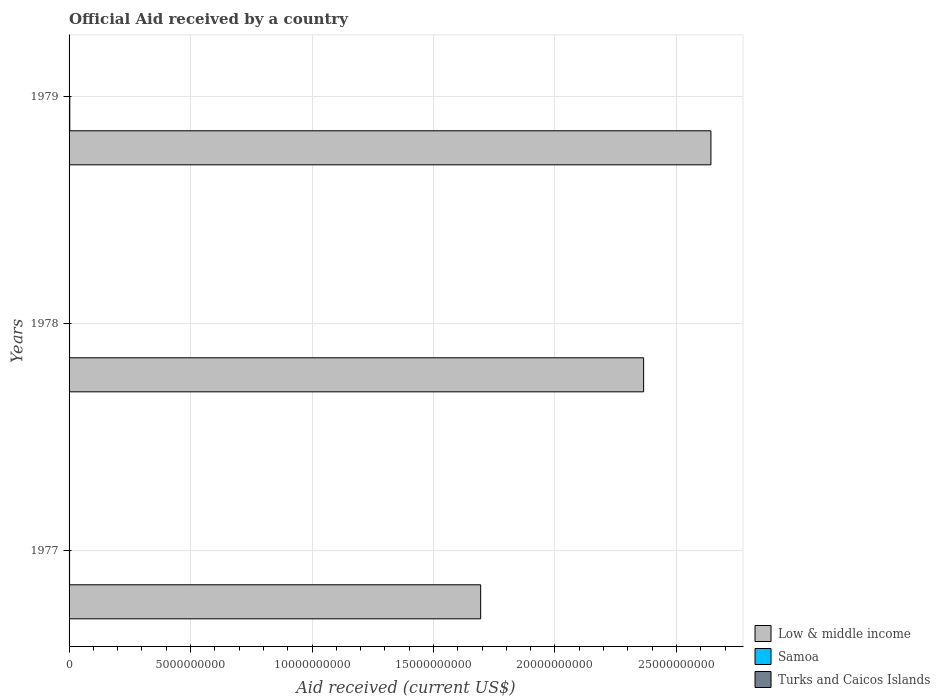How many bars are there on the 1st tick from the bottom?
Provide a short and direct response. 3. In how many cases, is the number of bars for a given year not equal to the number of legend labels?
Offer a very short reply. 0. What is the net official aid received in Samoa in 1977?
Your answer should be very brief. 2.00e+07. Across all years, what is the maximum net official aid received in Samoa?
Ensure brevity in your answer.  2.96e+07. Across all years, what is the minimum net official aid received in Low & middle income?
Keep it short and to the point. 1.69e+1. In which year was the net official aid received in Samoa minimum?
Keep it short and to the point. 1978. What is the total net official aid received in Samoa in the graph?
Your response must be concise. 6.96e+07. What is the difference between the net official aid received in Turks and Caicos Islands in 1978 and that in 1979?
Ensure brevity in your answer.  4.60e+05. What is the difference between the net official aid received in Low & middle income in 1979 and the net official aid received in Turks and Caicos Islands in 1978?
Your response must be concise. 2.64e+1. What is the average net official aid received in Turks and Caicos Islands per year?
Offer a terse response. 2.85e+06. In the year 1977, what is the difference between the net official aid received in Samoa and net official aid received in Low & middle income?
Provide a succinct answer. -1.69e+1. What is the ratio of the net official aid received in Turks and Caicos Islands in 1977 to that in 1979?
Make the answer very short. 1.49. Is the net official aid received in Low & middle income in 1977 less than that in 1978?
Your answer should be compact. Yes. What is the difference between the highest and the second highest net official aid received in Samoa?
Make the answer very short. 9.61e+06. What is the difference between the highest and the lowest net official aid received in Low & middle income?
Ensure brevity in your answer.  9.48e+09. Is the sum of the net official aid received in Turks and Caicos Islands in 1978 and 1979 greater than the maximum net official aid received in Low & middle income across all years?
Keep it short and to the point. No. What does the 2nd bar from the bottom in 1979 represents?
Offer a terse response. Samoa. How many bars are there?
Give a very brief answer. 9. Are all the bars in the graph horizontal?
Your answer should be very brief. Yes. Does the graph contain any zero values?
Offer a very short reply. No. Does the graph contain grids?
Ensure brevity in your answer.  Yes. How many legend labels are there?
Offer a terse response. 3. How are the legend labels stacked?
Offer a very short reply. Vertical. What is the title of the graph?
Offer a terse response. Official Aid received by a country. What is the label or title of the X-axis?
Give a very brief answer. Aid received (current US$). What is the label or title of the Y-axis?
Ensure brevity in your answer.  Years. What is the Aid received (current US$) in Low & middle income in 1977?
Your answer should be compact. 1.69e+1. What is the Aid received (current US$) in Samoa in 1977?
Provide a succinct answer. 2.00e+07. What is the Aid received (current US$) of Turks and Caicos Islands in 1977?
Offer a terse response. 3.45e+06. What is the Aid received (current US$) in Low & middle income in 1978?
Give a very brief answer. 2.37e+1. What is the Aid received (current US$) of Samoa in 1978?
Ensure brevity in your answer.  1.99e+07. What is the Aid received (current US$) in Turks and Caicos Islands in 1978?
Give a very brief answer. 2.78e+06. What is the Aid received (current US$) in Low & middle income in 1979?
Ensure brevity in your answer.  2.64e+1. What is the Aid received (current US$) of Samoa in 1979?
Your answer should be very brief. 2.96e+07. What is the Aid received (current US$) of Turks and Caicos Islands in 1979?
Ensure brevity in your answer.  2.32e+06. Across all years, what is the maximum Aid received (current US$) of Low & middle income?
Your answer should be very brief. 2.64e+1. Across all years, what is the maximum Aid received (current US$) in Samoa?
Your answer should be compact. 2.96e+07. Across all years, what is the maximum Aid received (current US$) of Turks and Caicos Islands?
Offer a very short reply. 3.45e+06. Across all years, what is the minimum Aid received (current US$) in Low & middle income?
Keep it short and to the point. 1.69e+1. Across all years, what is the minimum Aid received (current US$) of Samoa?
Ensure brevity in your answer.  1.99e+07. Across all years, what is the minimum Aid received (current US$) of Turks and Caicos Islands?
Ensure brevity in your answer.  2.32e+06. What is the total Aid received (current US$) of Low & middle income in the graph?
Offer a very short reply. 6.70e+1. What is the total Aid received (current US$) of Samoa in the graph?
Offer a very short reply. 6.96e+07. What is the total Aid received (current US$) in Turks and Caicos Islands in the graph?
Provide a short and direct response. 8.55e+06. What is the difference between the Aid received (current US$) in Low & middle income in 1977 and that in 1978?
Provide a succinct answer. -6.71e+09. What is the difference between the Aid received (current US$) in Turks and Caicos Islands in 1977 and that in 1978?
Make the answer very short. 6.70e+05. What is the difference between the Aid received (current US$) in Low & middle income in 1977 and that in 1979?
Your answer should be compact. -9.48e+09. What is the difference between the Aid received (current US$) in Samoa in 1977 and that in 1979?
Provide a short and direct response. -9.61e+06. What is the difference between the Aid received (current US$) of Turks and Caicos Islands in 1977 and that in 1979?
Your response must be concise. 1.13e+06. What is the difference between the Aid received (current US$) in Low & middle income in 1978 and that in 1979?
Keep it short and to the point. -2.77e+09. What is the difference between the Aid received (current US$) of Samoa in 1978 and that in 1979?
Provide a succinct answer. -9.76e+06. What is the difference between the Aid received (current US$) in Turks and Caicos Islands in 1978 and that in 1979?
Your response must be concise. 4.60e+05. What is the difference between the Aid received (current US$) in Low & middle income in 1977 and the Aid received (current US$) in Samoa in 1978?
Give a very brief answer. 1.69e+1. What is the difference between the Aid received (current US$) in Low & middle income in 1977 and the Aid received (current US$) in Turks and Caicos Islands in 1978?
Give a very brief answer. 1.69e+1. What is the difference between the Aid received (current US$) of Samoa in 1977 and the Aid received (current US$) of Turks and Caicos Islands in 1978?
Keep it short and to the point. 1.73e+07. What is the difference between the Aid received (current US$) in Low & middle income in 1977 and the Aid received (current US$) in Samoa in 1979?
Your answer should be very brief. 1.69e+1. What is the difference between the Aid received (current US$) in Low & middle income in 1977 and the Aid received (current US$) in Turks and Caicos Islands in 1979?
Provide a short and direct response. 1.69e+1. What is the difference between the Aid received (current US$) of Samoa in 1977 and the Aid received (current US$) of Turks and Caicos Islands in 1979?
Ensure brevity in your answer.  1.77e+07. What is the difference between the Aid received (current US$) of Low & middle income in 1978 and the Aid received (current US$) of Samoa in 1979?
Your response must be concise. 2.36e+1. What is the difference between the Aid received (current US$) in Low & middle income in 1978 and the Aid received (current US$) in Turks and Caicos Islands in 1979?
Keep it short and to the point. 2.36e+1. What is the difference between the Aid received (current US$) of Samoa in 1978 and the Aid received (current US$) of Turks and Caicos Islands in 1979?
Give a very brief answer. 1.76e+07. What is the average Aid received (current US$) in Low & middle income per year?
Provide a short and direct response. 2.23e+1. What is the average Aid received (current US$) of Samoa per year?
Keep it short and to the point. 2.32e+07. What is the average Aid received (current US$) of Turks and Caicos Islands per year?
Offer a very short reply. 2.85e+06. In the year 1977, what is the difference between the Aid received (current US$) of Low & middle income and Aid received (current US$) of Samoa?
Ensure brevity in your answer.  1.69e+1. In the year 1977, what is the difference between the Aid received (current US$) in Low & middle income and Aid received (current US$) in Turks and Caicos Islands?
Offer a very short reply. 1.69e+1. In the year 1977, what is the difference between the Aid received (current US$) of Samoa and Aid received (current US$) of Turks and Caicos Islands?
Give a very brief answer. 1.66e+07. In the year 1978, what is the difference between the Aid received (current US$) in Low & middle income and Aid received (current US$) in Samoa?
Make the answer very short. 2.36e+1. In the year 1978, what is the difference between the Aid received (current US$) in Low & middle income and Aid received (current US$) in Turks and Caicos Islands?
Provide a short and direct response. 2.36e+1. In the year 1978, what is the difference between the Aid received (current US$) in Samoa and Aid received (current US$) in Turks and Caicos Islands?
Provide a short and direct response. 1.71e+07. In the year 1979, what is the difference between the Aid received (current US$) of Low & middle income and Aid received (current US$) of Samoa?
Your answer should be compact. 2.64e+1. In the year 1979, what is the difference between the Aid received (current US$) in Low & middle income and Aid received (current US$) in Turks and Caicos Islands?
Provide a short and direct response. 2.64e+1. In the year 1979, what is the difference between the Aid received (current US$) of Samoa and Aid received (current US$) of Turks and Caicos Islands?
Keep it short and to the point. 2.73e+07. What is the ratio of the Aid received (current US$) of Low & middle income in 1977 to that in 1978?
Give a very brief answer. 0.72. What is the ratio of the Aid received (current US$) of Samoa in 1977 to that in 1978?
Your answer should be very brief. 1.01. What is the ratio of the Aid received (current US$) of Turks and Caicos Islands in 1977 to that in 1978?
Offer a terse response. 1.24. What is the ratio of the Aid received (current US$) in Low & middle income in 1977 to that in 1979?
Your response must be concise. 0.64. What is the ratio of the Aid received (current US$) of Samoa in 1977 to that in 1979?
Offer a terse response. 0.68. What is the ratio of the Aid received (current US$) in Turks and Caicos Islands in 1977 to that in 1979?
Ensure brevity in your answer.  1.49. What is the ratio of the Aid received (current US$) of Low & middle income in 1978 to that in 1979?
Give a very brief answer. 0.9. What is the ratio of the Aid received (current US$) in Samoa in 1978 to that in 1979?
Your answer should be very brief. 0.67. What is the ratio of the Aid received (current US$) in Turks and Caicos Islands in 1978 to that in 1979?
Your answer should be very brief. 1.2. What is the difference between the highest and the second highest Aid received (current US$) in Low & middle income?
Provide a succinct answer. 2.77e+09. What is the difference between the highest and the second highest Aid received (current US$) of Samoa?
Your answer should be very brief. 9.61e+06. What is the difference between the highest and the second highest Aid received (current US$) in Turks and Caicos Islands?
Offer a terse response. 6.70e+05. What is the difference between the highest and the lowest Aid received (current US$) in Low & middle income?
Your answer should be compact. 9.48e+09. What is the difference between the highest and the lowest Aid received (current US$) in Samoa?
Give a very brief answer. 9.76e+06. What is the difference between the highest and the lowest Aid received (current US$) of Turks and Caicos Islands?
Make the answer very short. 1.13e+06. 